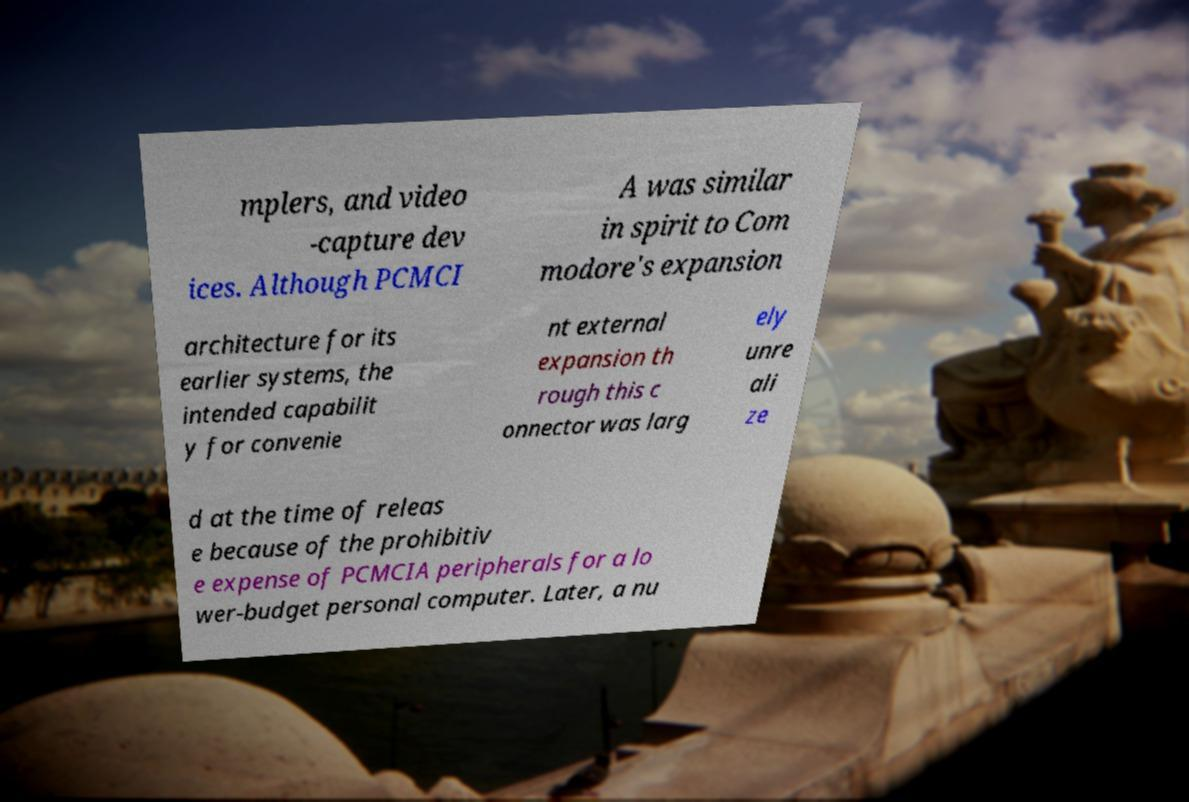What messages or text are displayed in this image? I need them in a readable, typed format. mplers, and video -capture dev ices. Although PCMCI A was similar in spirit to Com modore's expansion architecture for its earlier systems, the intended capabilit y for convenie nt external expansion th rough this c onnector was larg ely unre ali ze d at the time of releas e because of the prohibitiv e expense of PCMCIA peripherals for a lo wer-budget personal computer. Later, a nu 